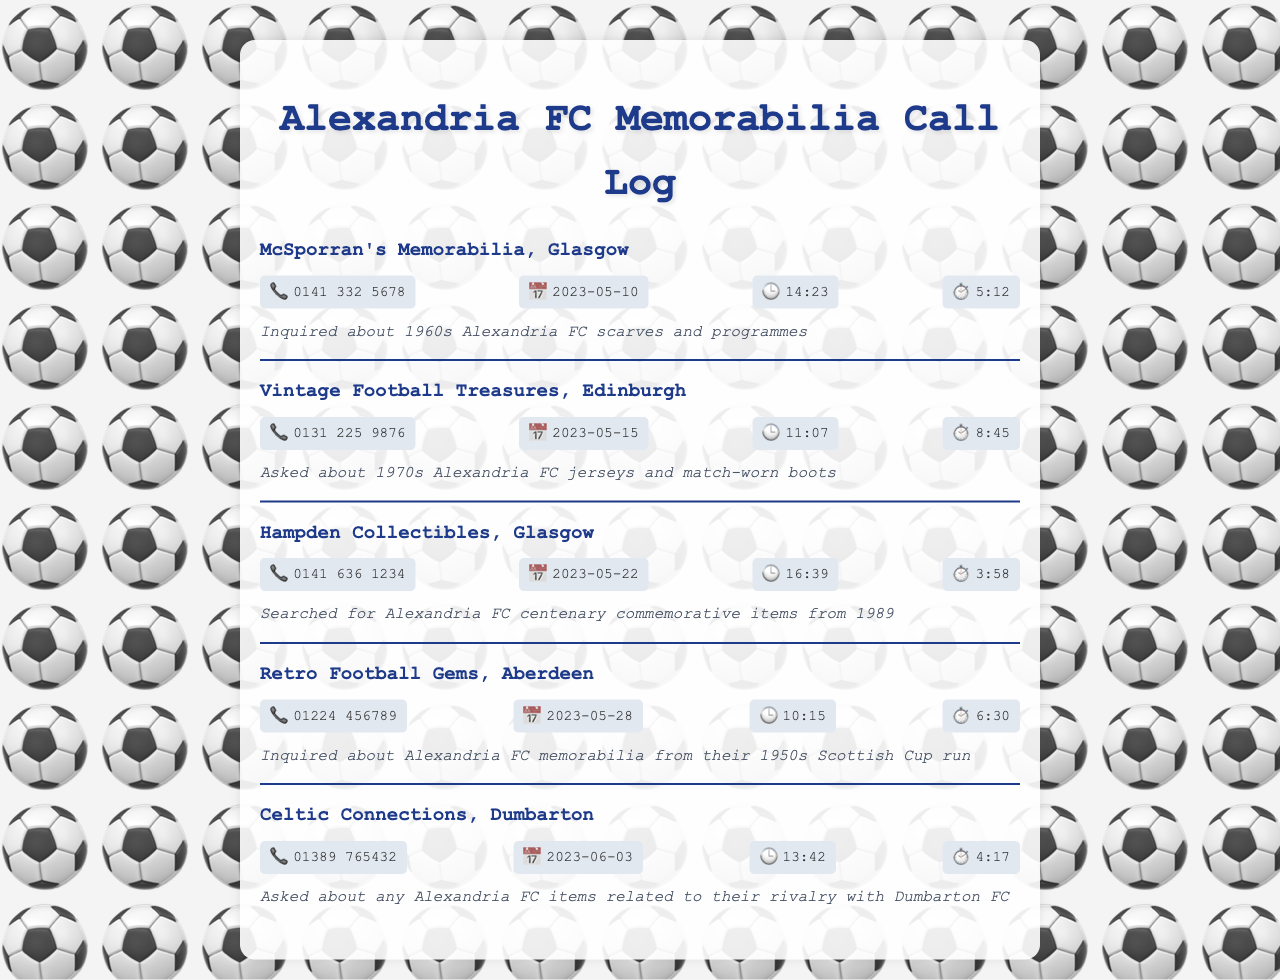What is the name of the first shop? The name of the first shop listed in the document is McSporran's Memorabilia, Glasgow.
Answer: McSporran's Memorabilia, Glasgow What date was the call made to Retro Football Gems? The date of the call to Retro Football Gems is found in the call details section. It was made on 2023-05-28.
Answer: 2023-05-28 How long was the call to Vintage Football Treasures? The duration of the call to Vintage Football Treasures is 8 minutes and 45 seconds.
Answer: 8:45 What item was inquired about at Hampden Collectibles? The inquiry at Hampden Collectibles was specifically about Alexandria FC centenary commemorative items from 1989.
Answer: Alexandria FC centenary commemorative items from 1989 Which shop was called regarding items related to Dumbarton FC? The shop called about items related to Dumbarton FC is Celtic Connections, Dumbarton.
Answer: Celtic Connections, Dumbarton 